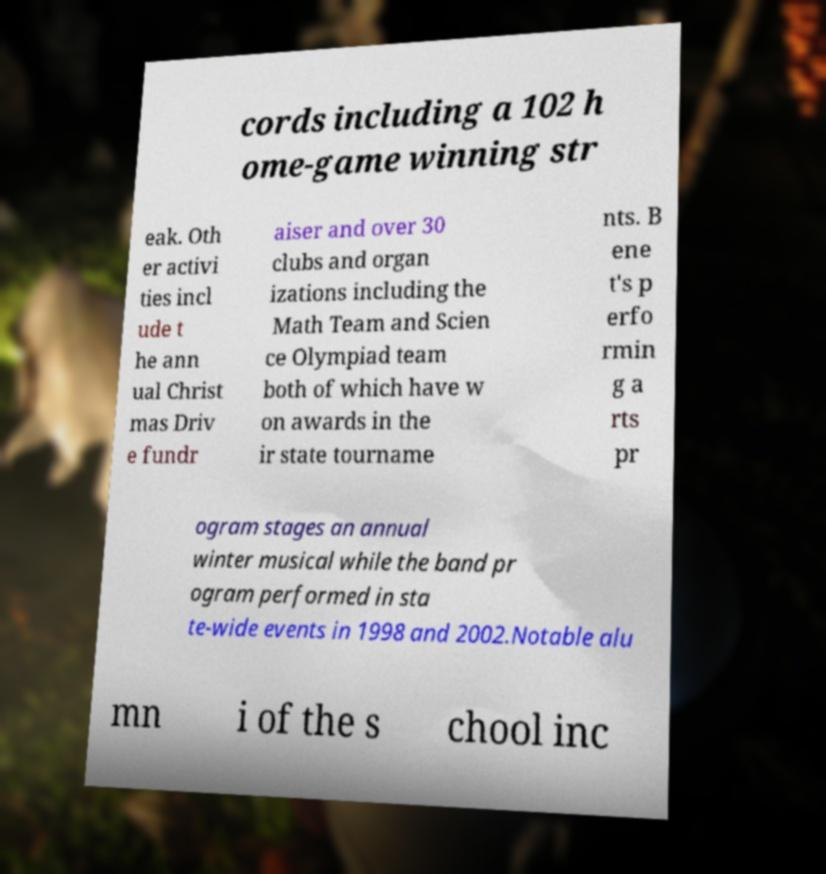Could you extract and type out the text from this image? cords including a 102 h ome-game winning str eak. Oth er activi ties incl ude t he ann ual Christ mas Driv e fundr aiser and over 30 clubs and organ izations including the Math Team and Scien ce Olympiad team both of which have w on awards in the ir state tourname nts. B ene t's p erfo rmin g a rts pr ogram stages an annual winter musical while the band pr ogram performed in sta te-wide events in 1998 and 2002.Notable alu mn i of the s chool inc 